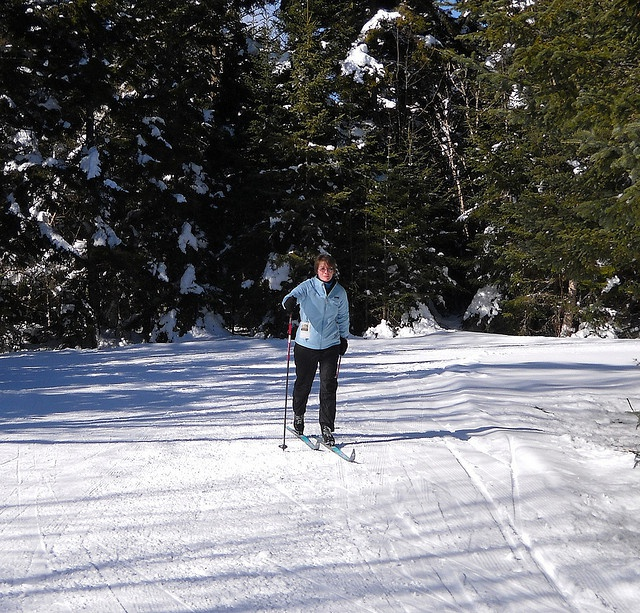Describe the objects in this image and their specific colors. I can see people in black and gray tones and skis in black, darkgray, lightgray, and gray tones in this image. 